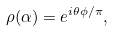Convert formula to latex. <formula><loc_0><loc_0><loc_500><loc_500>\rho ( \alpha ) = e ^ { i \theta \phi / \pi } ,</formula> 